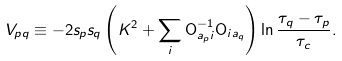Convert formula to latex. <formula><loc_0><loc_0><loc_500><loc_500>V _ { p q } \equiv - 2 s _ { p } s _ { q } \left ( K ^ { 2 } + \sum _ { i } { \mathsf O } ^ { - 1 } _ { a _ { p } i } { \mathsf O } _ { i a _ { q } } \right ) \ln \frac { \tau _ { q } - \tau _ { p } } { \tau _ { c } } .</formula> 